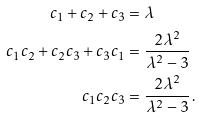Convert formula to latex. <formula><loc_0><loc_0><loc_500><loc_500>c _ { 1 } + c _ { 2 } + c _ { 3 } & = \lambda \\ c _ { 1 } c _ { 2 } + c _ { 2 } c _ { 3 } + c _ { 3 } c _ { 1 } & = \frac { 2 \lambda ^ { 2 } } { \lambda ^ { 2 } - 3 } \\ c _ { 1 } c _ { 2 } c _ { 3 } & = \frac { 2 \lambda ^ { 2 } } { \lambda ^ { 2 } - 3 } \, .</formula> 